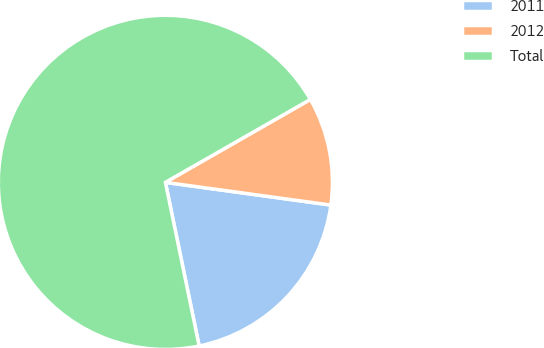Convert chart. <chart><loc_0><loc_0><loc_500><loc_500><pie_chart><fcel>2011<fcel>2012<fcel>Total<nl><fcel>19.59%<fcel>10.44%<fcel>69.97%<nl></chart> 